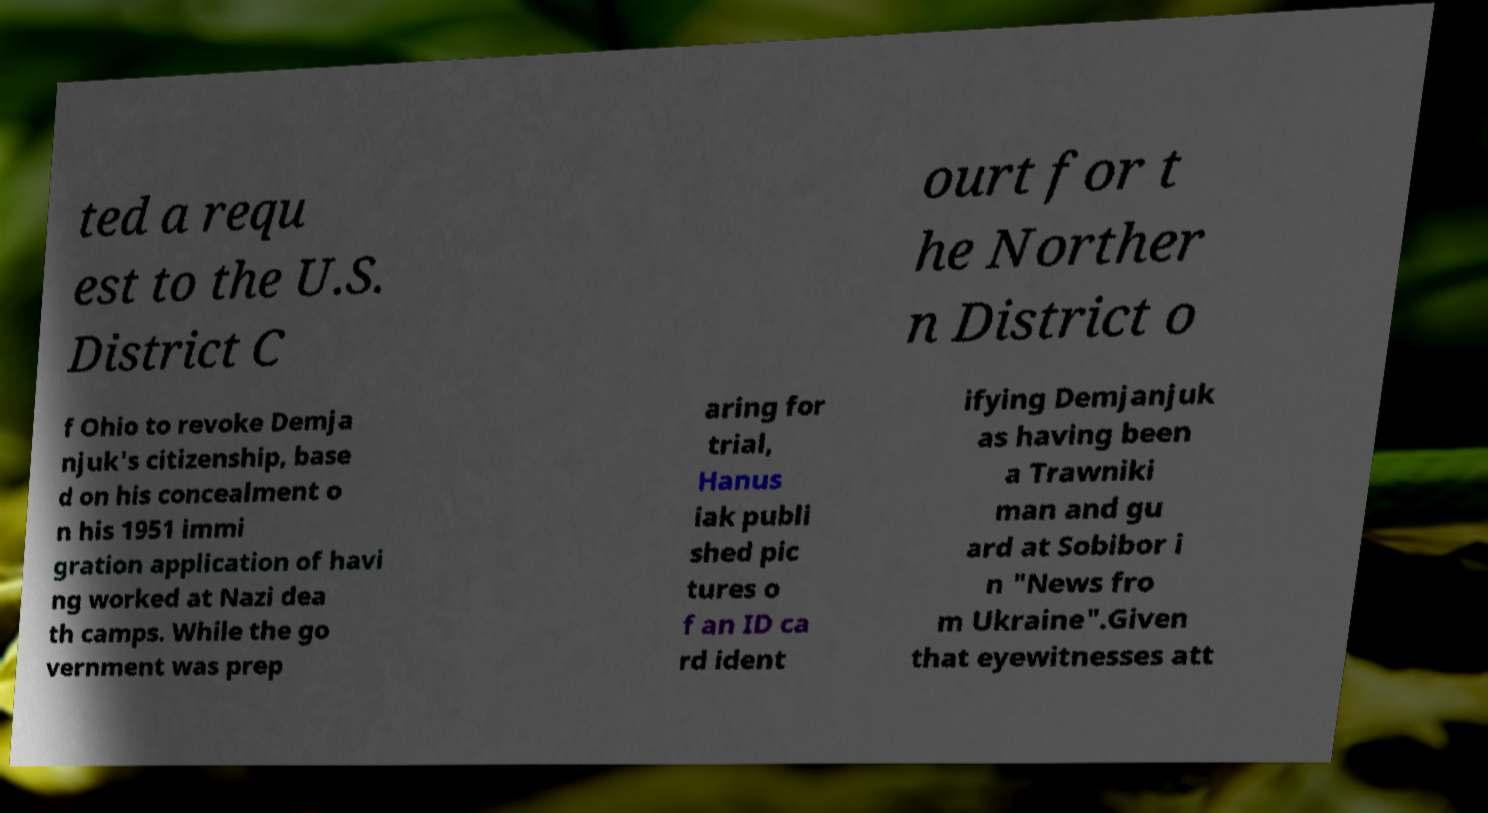For documentation purposes, I need the text within this image transcribed. Could you provide that? ted a requ est to the U.S. District C ourt for t he Norther n District o f Ohio to revoke Demja njuk's citizenship, base d on his concealment o n his 1951 immi gration application of havi ng worked at Nazi dea th camps. While the go vernment was prep aring for trial, Hanus iak publi shed pic tures o f an ID ca rd ident ifying Demjanjuk as having been a Trawniki man and gu ard at Sobibor i n "News fro m Ukraine".Given that eyewitnesses att 